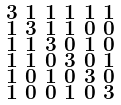<formula> <loc_0><loc_0><loc_500><loc_500>\begin{smallmatrix} 3 & 1 & 1 & 1 & 1 & 1 \\ 1 & 3 & 1 & 1 & 0 & 0 \\ 1 & 1 & 3 & 0 & 1 & 0 \\ 1 & 1 & 0 & 3 & 0 & 1 \\ 1 & 0 & 1 & 0 & 3 & 0 \\ 1 & 0 & 0 & 1 & 0 & 3 \end{smallmatrix}</formula> 